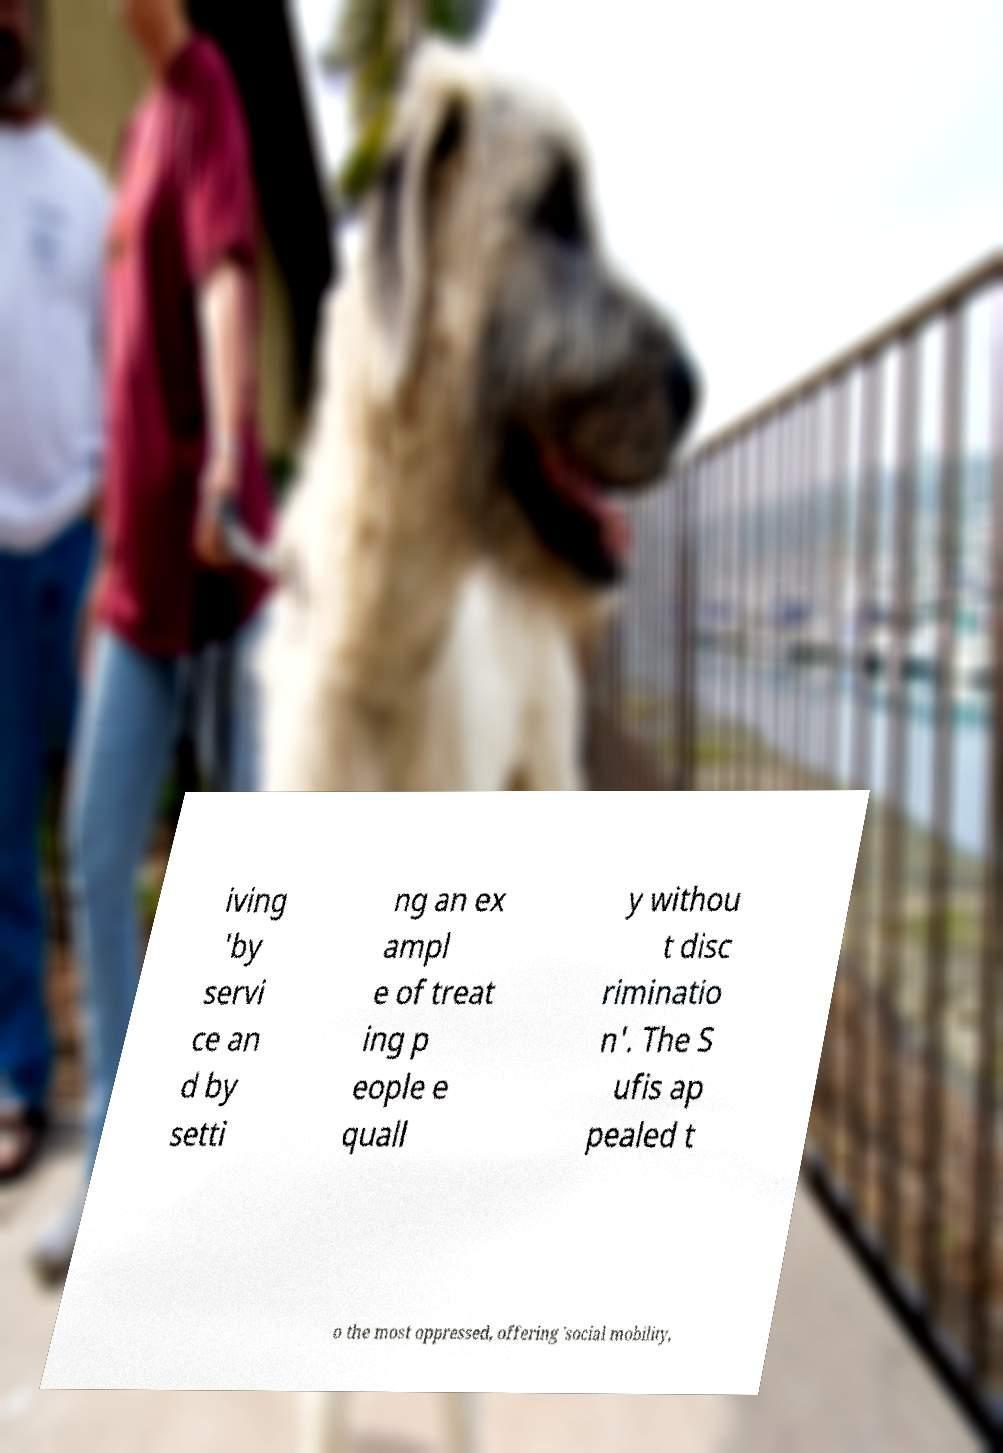For documentation purposes, I need the text within this image transcribed. Could you provide that? iving 'by servi ce an d by setti ng an ex ampl e of treat ing p eople e quall y withou t disc riminatio n'. The S ufis ap pealed t o the most oppressed, offering 'social mobility, 